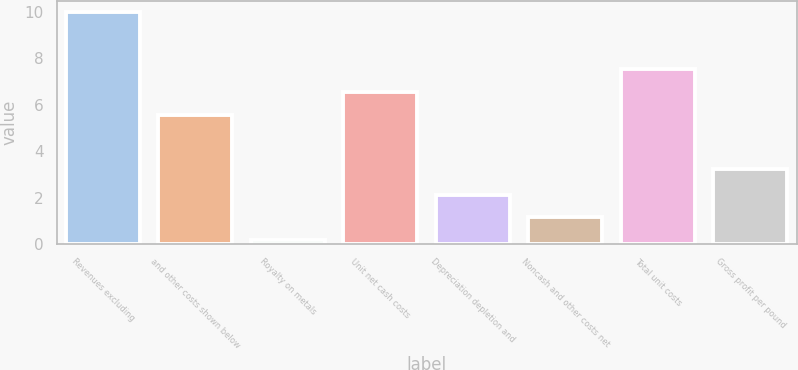Convert chart to OTSL. <chart><loc_0><loc_0><loc_500><loc_500><bar_chart><fcel>Revenues excluding<fcel>and other costs shown below<fcel>Royalty on metals<fcel>Unit net cash costs<fcel>Depreciation depletion and<fcel>Noncash and other costs net<fcel>Total unit costs<fcel>Gross profit per pound<nl><fcel>9.99<fcel>5.58<fcel>0.16<fcel>6.56<fcel>2.12<fcel>1.14<fcel>7.54<fcel>3.21<nl></chart> 